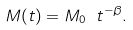<formula> <loc_0><loc_0><loc_500><loc_500>M ( t ) = M _ { 0 } \ t ^ { - \beta } .</formula> 